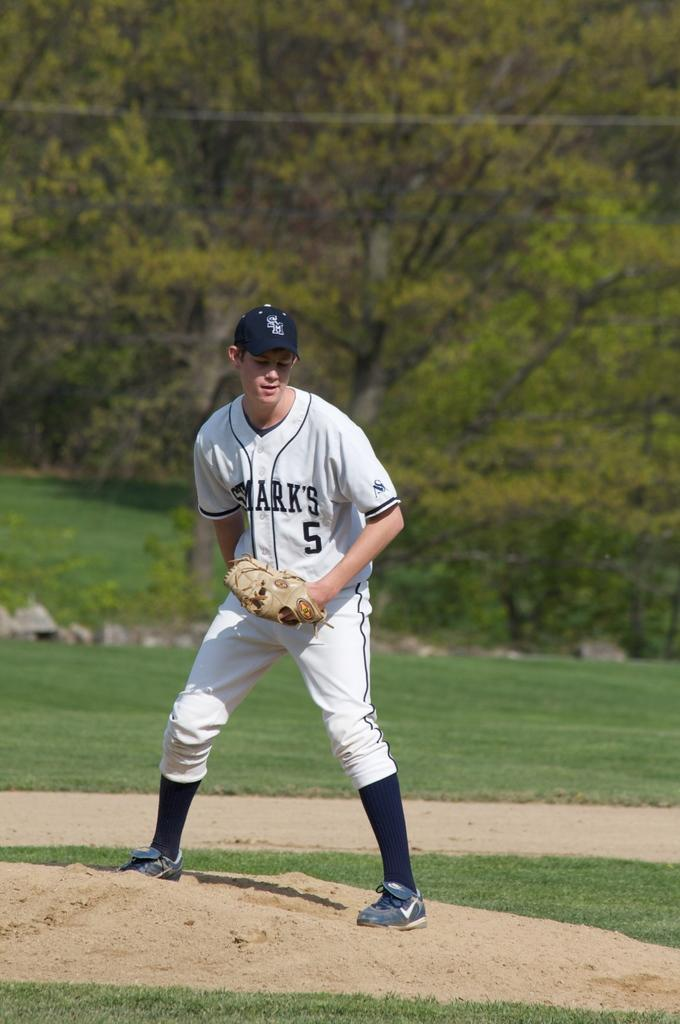<image>
Create a compact narrative representing the image presented. a baseball player in the outfield marks 5 